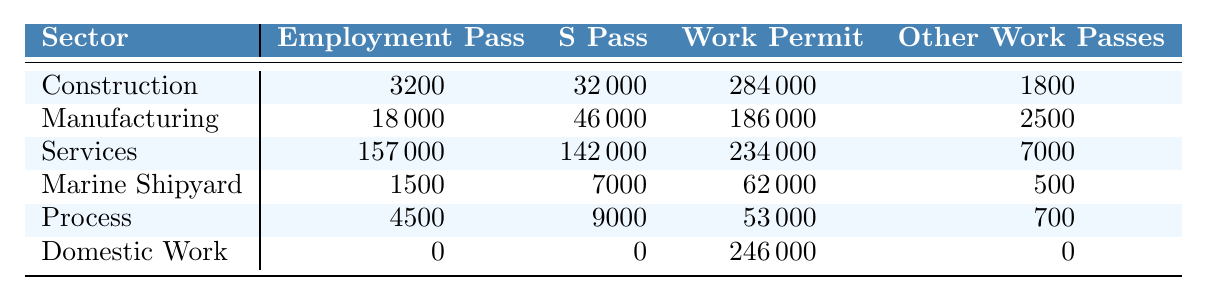What is the total number of Work Permit holders in the Construction sector? From the table, the number of Work Permit holders in the Construction sector is listed as 284,000.
Answer: 284000 Which sector has the highest number of Employment Pass holders? Looking at the table, the Services sector has the highest number of Employment Pass holders at 157,000.
Answer: 157000 How many more S Pass holders are there in the Manufacturing sector than in the Marine Shipyard sector? The Manufacturing sector has 46,000 S Pass holders while the Marine Shipyard sector has 7,000. The difference is 46,000 - 7,000 = 39,000.
Answer: 39000 Is there any sector that does not have Employment Pass holders? The table shows that the Domestic Work sector has 0 Employment Pass holders, verifying that there is indeed a sector without them.
Answer: Yes What is the total number of Work Pass holders in the Services sector? For the Services sector, the total number of Work Pass holders can be calculated by adding up: 157,000 (Employment Pass) + 142,000 (S Pass) + 234,000 (Work Permit) + 7,000 (Other Work Passes) = 540,000.
Answer: 540000 Which sector has the least number of Other Work Pass holders? In the Domestic Work sector, the number of Other Work Pass holders is 0, which is the least compared to other sectors that all have positive values.
Answer: Domestic Work Calculate the average number of Employment Pass holders across all sectors. The total number of Employment Pass holders is 3200 (Construction) + 18000 (Manufacturing) + 157000 (Services) + 1500 (Marine Shipyard) + 4500 (Process) + 0 (Domestic Work) = 178,200. There are 6 sectors, so the average is 178,200 / 6 = 29,700.
Answer: 29700 Does the Services sector have more Work Permit holders than the combined total of Work Permit holders in the Marine Shipyard and Process sectors? The Services sector has 234,000 Work Permit holders, while the Marine Shipyard and Process sectors have a combined total of 62,000 + 53,000 = 115,000 Work Permit holders. Thus, 234,000 is greater than 115,000, confirming the statement is true.
Answer: Yes What is the combined total number of S Pass and Other Work Pass holders in the Construction sector? In the Construction sector, the S Pass holders are 32,000 and Other Work Passes are 1,800. The total is 32,000 + 1,800 = 33,800.
Answer: 33800 How does the total number of Work Permit holders in Domestic Work compare to the sum of Work Permit holders in the Construction and Marine Shipyard sectors? The Domestic Work sector has 246,000 Work Permit holders. The sum of Work Permit holders in the Construction (284,000) and Marine Shipyard (62,000) sectors is 284,000 + 62,000 = 346,000. Since 246,000 is less than 346,000, Domestic Work has fewer Work Permit holders.
Answer: Less 